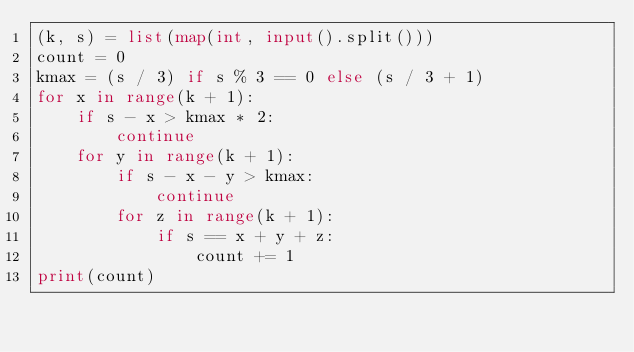Convert code to text. <code><loc_0><loc_0><loc_500><loc_500><_Python_>(k, s) = list(map(int, input().split()))
count = 0
kmax = (s / 3) if s % 3 == 0 else (s / 3 + 1)
for x in range(k + 1):
    if s - x > kmax * 2:
        continue
    for y in range(k + 1):
        if s - x - y > kmax:
            continue
        for z in range(k + 1):
            if s == x + y + z:
                count += 1
print(count)</code> 